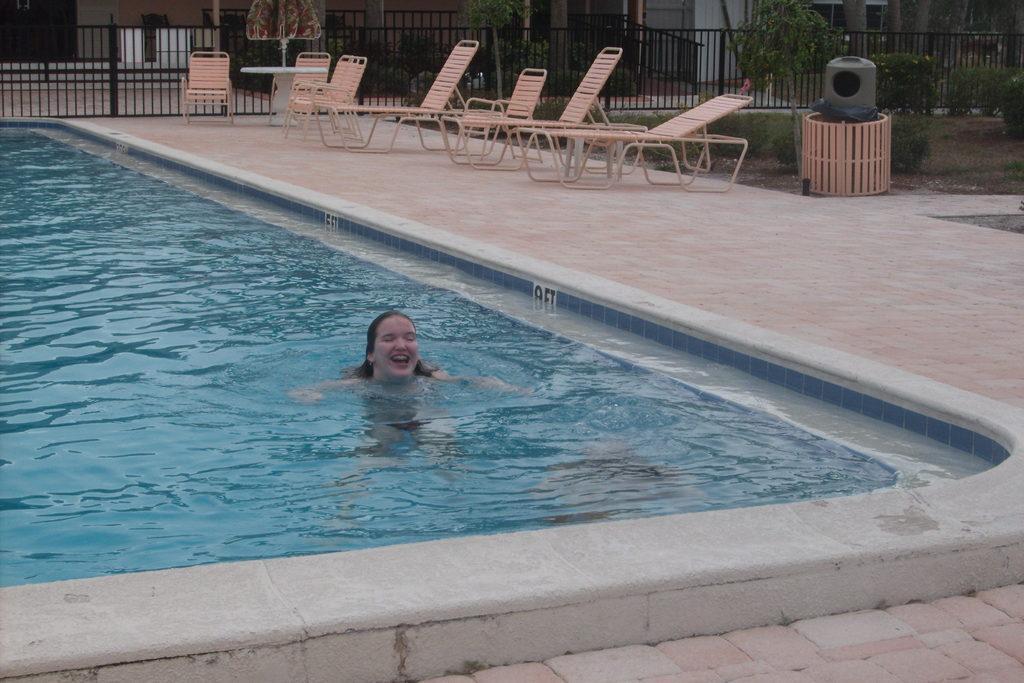How would you summarize this image in a sentence or two? In the center of the image we can see a lady is present in a pool. In the background of the image we can see the chairs, grilles, table, umbrella, plants, grass, floor, wall. 